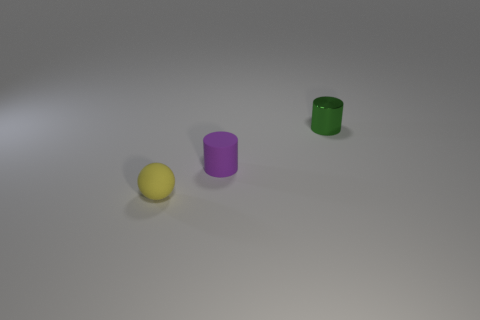What number of other objects are the same color as the tiny rubber sphere? There are 0 other objects sharing the same yellow color as the tiny rubber sphere in the image. 